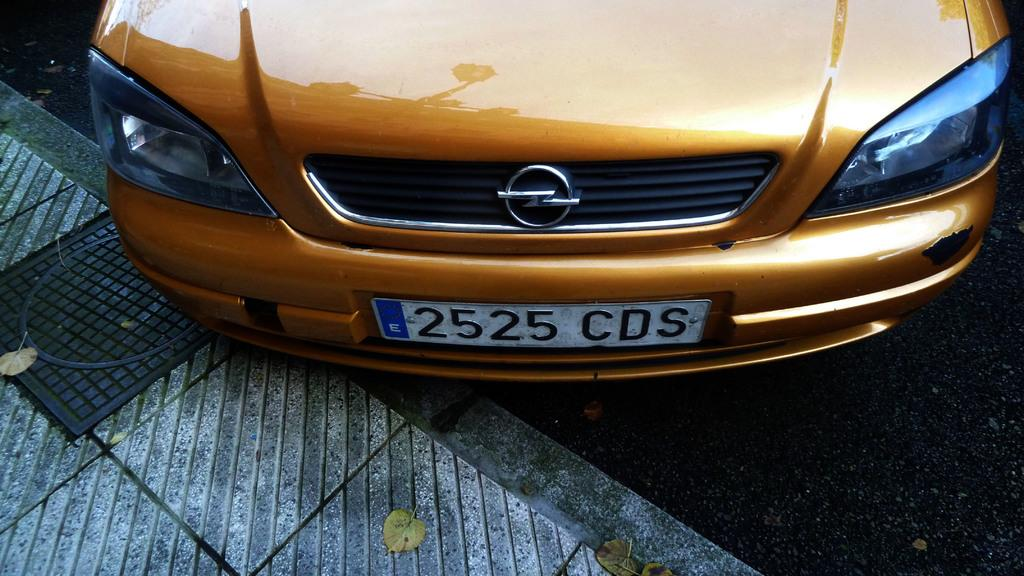What is the main subject of the image? There is a car in the image. Can you describe the car's appearance? The car is gold in color. What else can be seen in the image besides the car? There is a footpath, a manhole on the left side, and a road in the image. Can you tell me how many times the man jumps over the car in the image? There is no man present in the image, and therefore no jumping can be observed. What type of cap is the man wearing in the image? There is no man present in the image, and therefore no cap can be observed. 